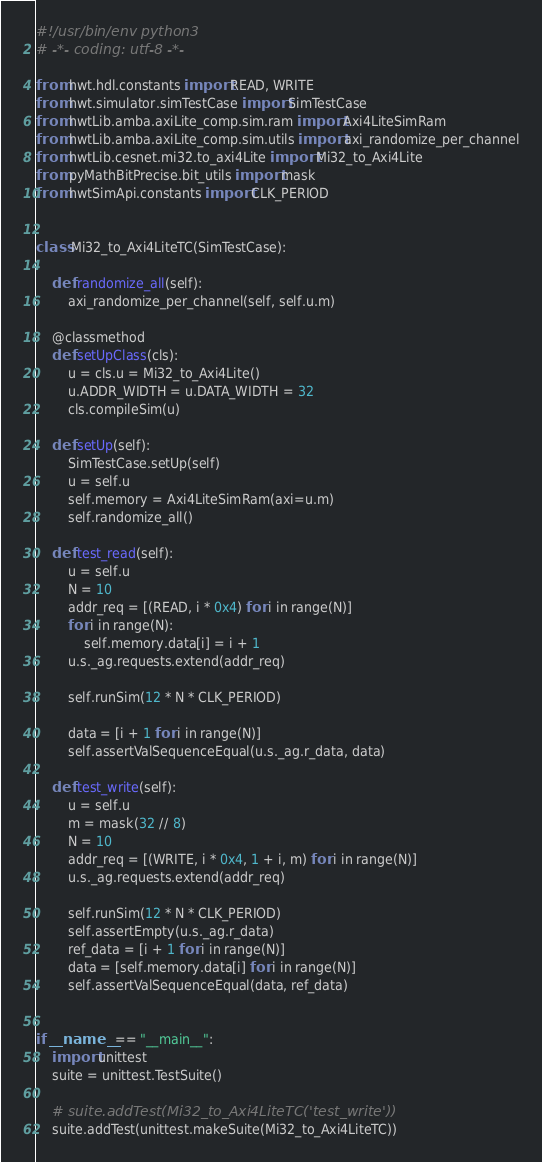Convert code to text. <code><loc_0><loc_0><loc_500><loc_500><_Python_>#!/usr/bin/env python3
# -*- coding: utf-8 -*-

from hwt.hdl.constants import READ, WRITE
from hwt.simulator.simTestCase import SimTestCase
from hwtLib.amba.axiLite_comp.sim.ram import Axi4LiteSimRam
from hwtLib.amba.axiLite_comp.sim.utils import axi_randomize_per_channel
from hwtLib.cesnet.mi32.to_axi4Lite import Mi32_to_Axi4Lite
from pyMathBitPrecise.bit_utils import mask
from hwtSimApi.constants import CLK_PERIOD


class Mi32_to_Axi4LiteTC(SimTestCase):

    def randomize_all(self):
        axi_randomize_per_channel(self, self.u.m)

    @classmethod
    def setUpClass(cls):
        u = cls.u = Mi32_to_Axi4Lite()
        u.ADDR_WIDTH = u.DATA_WIDTH = 32
        cls.compileSim(u)

    def setUp(self):
        SimTestCase.setUp(self)
        u = self.u
        self.memory = Axi4LiteSimRam(axi=u.m)
        self.randomize_all()

    def test_read(self):
        u = self.u
        N = 10
        addr_req = [(READ, i * 0x4) for i in range(N)]
        for i in range(N):
            self.memory.data[i] = i + 1
        u.s._ag.requests.extend(addr_req)

        self.runSim(12 * N * CLK_PERIOD)

        data = [i + 1 for i in range(N)]
        self.assertValSequenceEqual(u.s._ag.r_data, data)

    def test_write(self):
        u = self.u
        m = mask(32 // 8)
        N = 10
        addr_req = [(WRITE, i * 0x4, 1 + i, m) for i in range(N)]
        u.s._ag.requests.extend(addr_req)

        self.runSim(12 * N * CLK_PERIOD)
        self.assertEmpty(u.s._ag.r_data)
        ref_data = [i + 1 for i in range(N)]
        data = [self.memory.data[i] for i in range(N)]
        self.assertValSequenceEqual(data, ref_data)


if __name__ == "__main__":
    import unittest
    suite = unittest.TestSuite()

    # suite.addTest(Mi32_to_Axi4LiteTC('test_write'))
    suite.addTest(unittest.makeSuite(Mi32_to_Axi4LiteTC))
</code> 